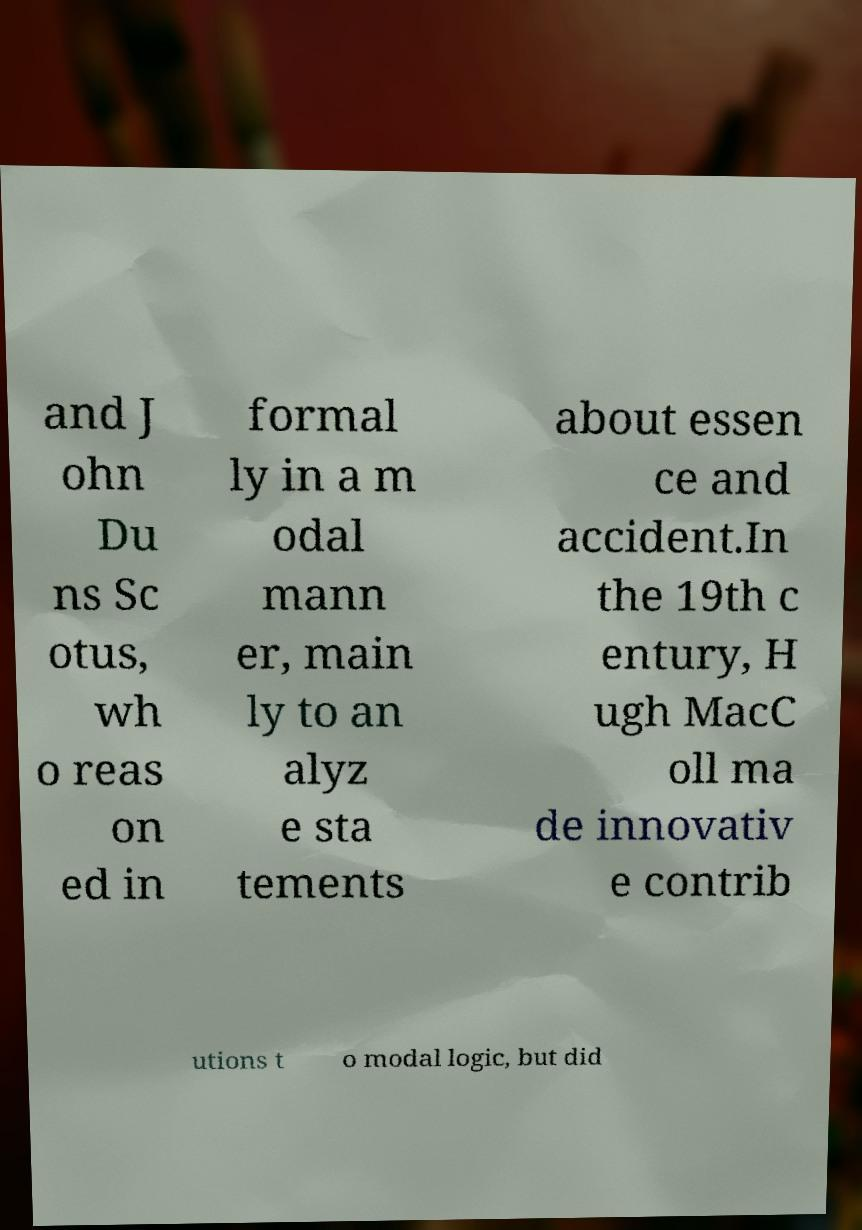Please identify and transcribe the text found in this image. and J ohn Du ns Sc otus, wh o reas on ed in formal ly in a m odal mann er, main ly to an alyz e sta tements about essen ce and accident.In the 19th c entury, H ugh MacC oll ma de innovativ e contrib utions t o modal logic, but did 